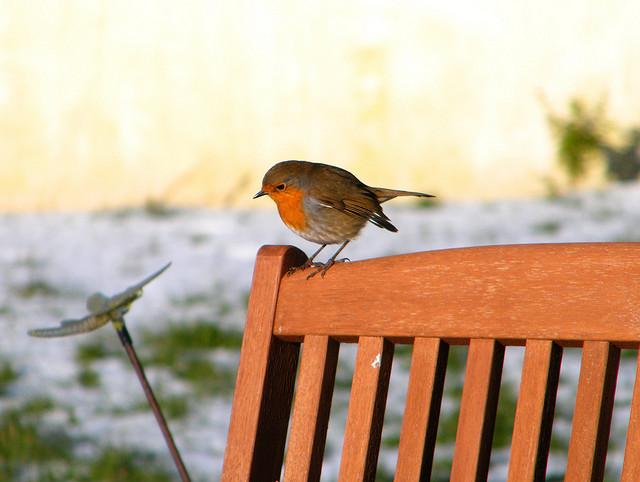What is the bird on?
Write a very short answer. Bench. Is this a migratory bird?
Be succinct. No. What is sticking out next to the chair?
Quick response, please. Bird. 